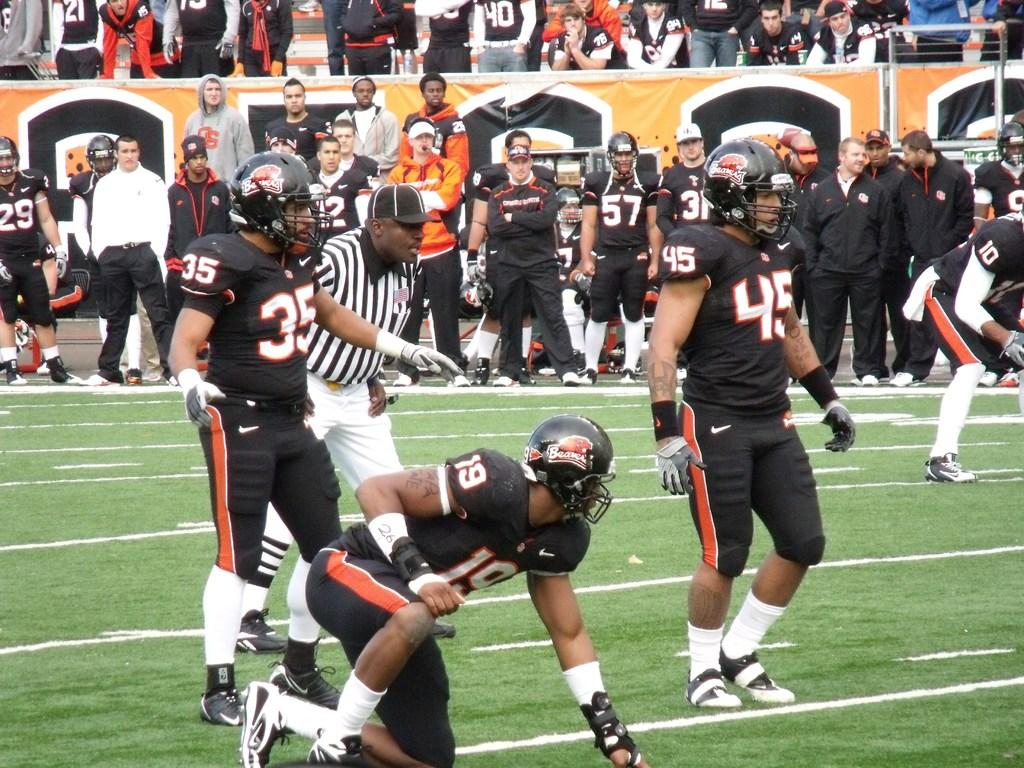What is the main activity of the people in the image? The main activity of the people in the image is standing in groups. Can you describe the position of one person in the image? Yes, there is a person sitting in a squat position in the image. What type of advertisement or display is the image likely to be? The image appears to be a hoarding. Where might this image be located? The setting is likely on a ground or similar outdoor area. What type of jam is being spread on the bag in the image? There is no jam or bag present in the image; it features groups of people standing and a person sitting in a squat position. 